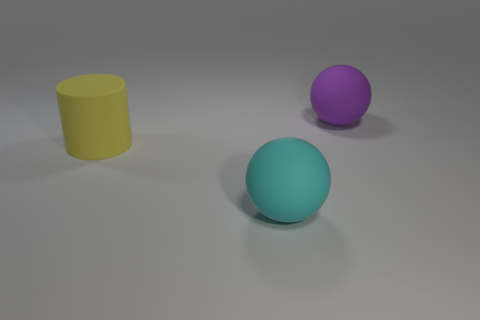Add 3 small green shiny balls. How many objects exist? 6 Subtract all purple balls. Subtract all green cylinders. How many balls are left? 1 Subtract all cylinders. How many objects are left? 2 Subtract all tiny green matte balls. Subtract all cyan things. How many objects are left? 2 Add 2 large yellow rubber objects. How many large yellow rubber objects are left? 3 Add 1 tiny green matte cylinders. How many tiny green matte cylinders exist? 1 Subtract 0 cyan cylinders. How many objects are left? 3 